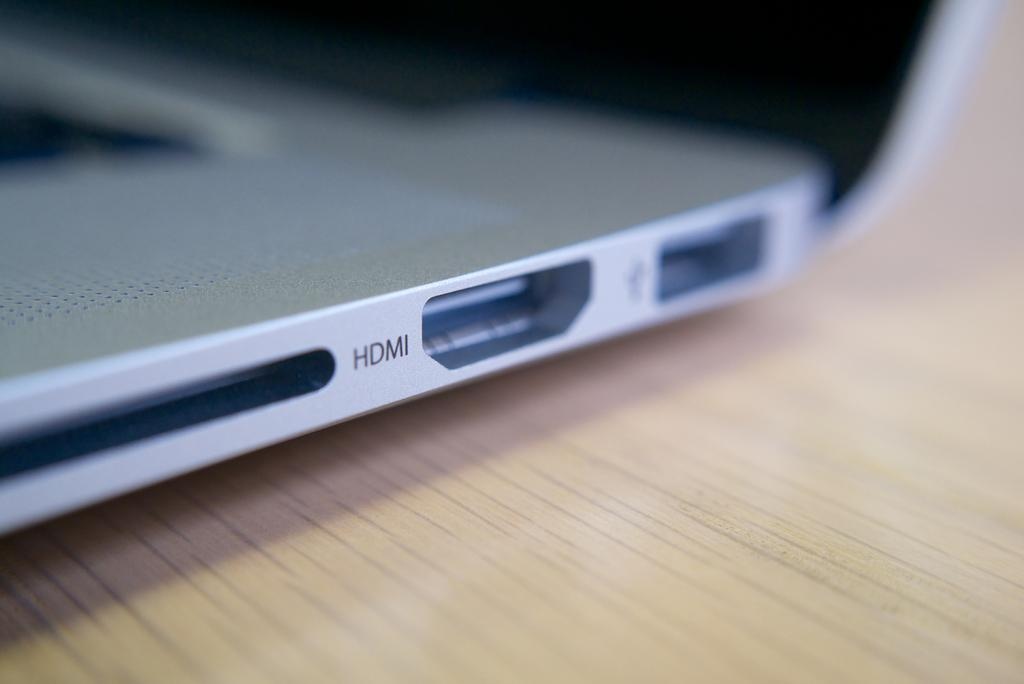<image>
Present a compact description of the photo's key features. a somewhat blurry picture of what seems to be a laptop showing HDMI outlet on a table. 